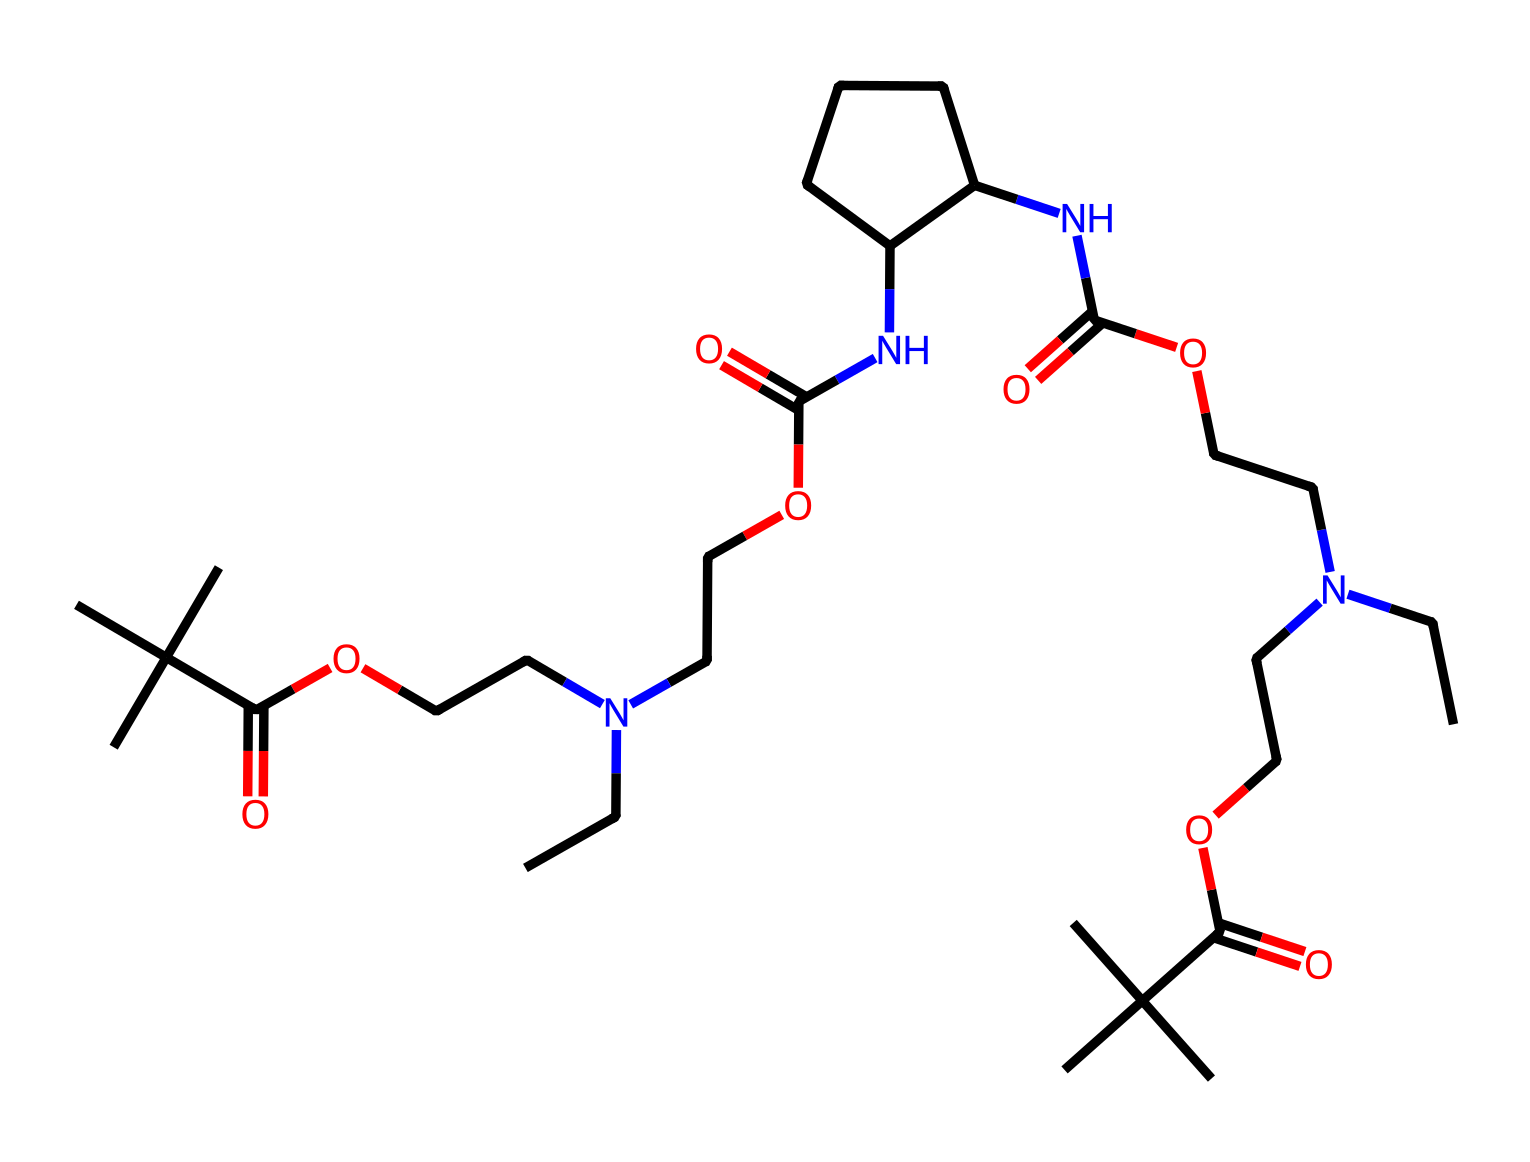What is the primary functional group present in this chemical? The chemical structure shows multiple occurrences of the carboxylic acid functional group (-COOH) and amide group (-CONH-). The most prominent functional group among these is the carboxylic acid due to its distinct structure.
Answer: carboxylic acid How many nitrogen atoms are in the molecule? By examining the SMILES representation, the nitrogen atoms ('N') can be counted. The structure shows a total of four nitrogen atoms present in different parts of the molecule.
Answer: four What type of bonding is likely to occur due to the presence of multiple amide groups? Amides can form hydrogen bonds due to the presence of a carbonyl oxygen and an amine hydrogen, which facilitate interactions between molecules. Therefore, we expect hydrogen bonding.
Answer: hydrogen bonding Which feature of this chemical contributes to its elasticity in spandex fibers? The presence of segments such as long aliphatic chains and the flexible nature of amide linkages allows for stretching and returning to the original shape, which is crucial for elasticity.
Answer: flexible chains How many ester linkages can be identified in the molecule? The structure contains ester groups formed by -COO- linkages, which can be counted through the structure. There are two identifiable ester linkages present.
Answer: two What characteristic does the branching (indicated by the 'C(C)(C)') impart to the polymer? The branching structure leads to a lower density and higher flexibility in the polymer chains, contributing to the overall performance characteristics of spandex, such as stretchability and comfort.
Answer: flexibility 